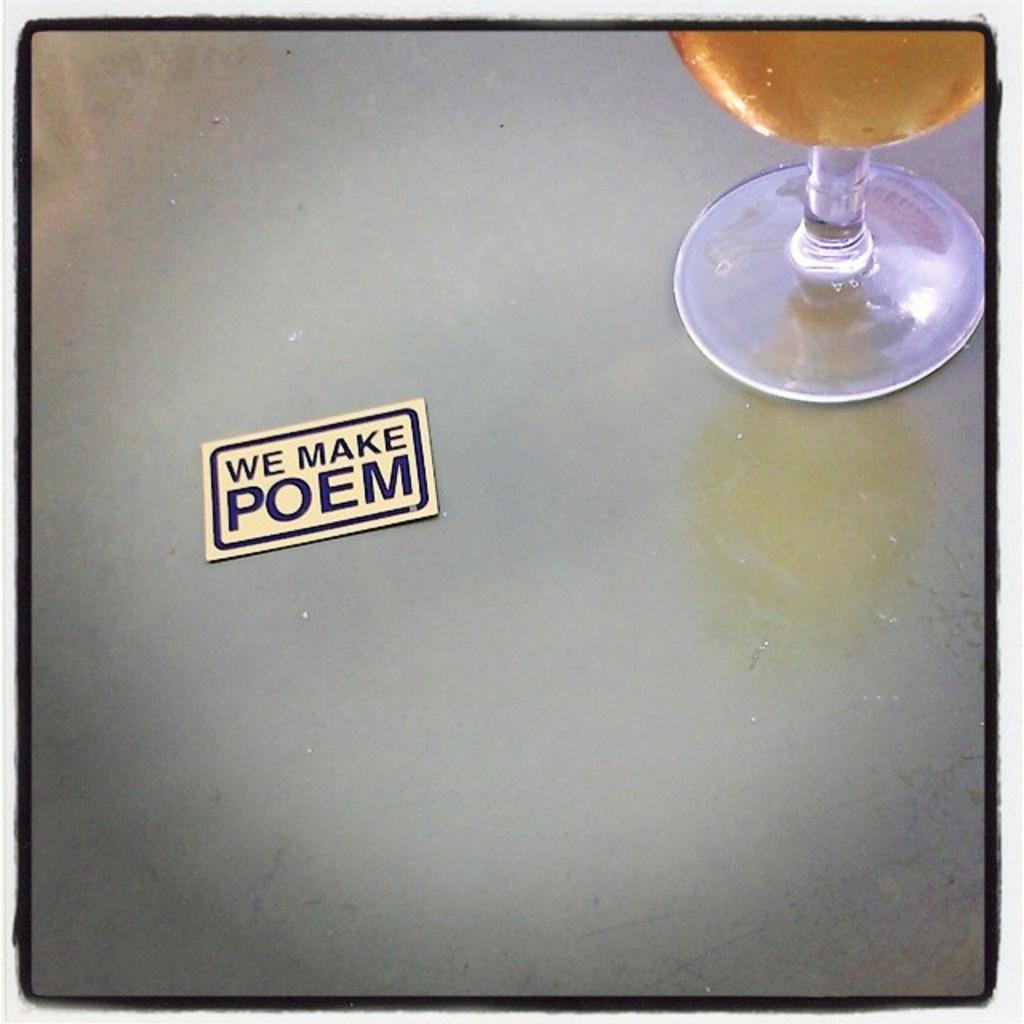What is inside the glass that is visible in the image? There is a liquid inside the glass in the image. Where is the glass located in the image? The glass is placed on a table in the image. What is the other item visible on the table in the image? There is a piece of chart with text in the image. Where is the chart located in the image? The chart is placed on the table in the image. What type of steel is used to make the crook in the image? There is no crook or steel present in the image. 